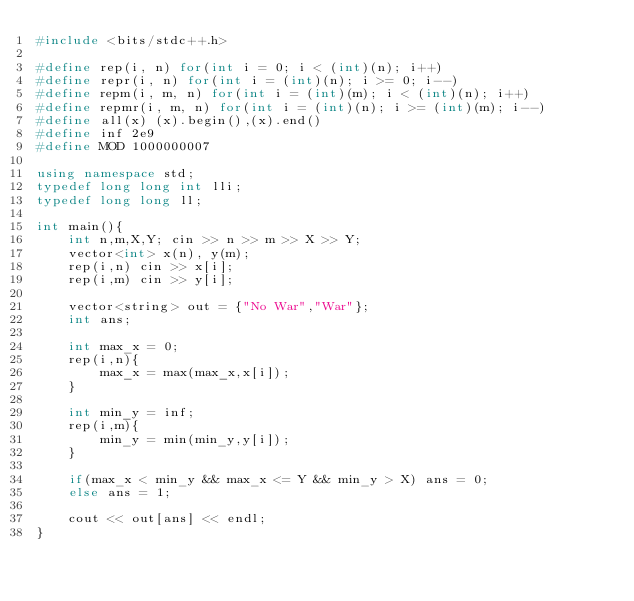<code> <loc_0><loc_0><loc_500><loc_500><_C++_>#include <bits/stdc++.h>

#define rep(i, n) for(int i = 0; i < (int)(n); i++)
#define repr(i, n) for(int i = (int)(n); i >= 0; i--)
#define repm(i, m, n) for(int i = (int)(m); i < (int)(n); i++)
#define repmr(i, m, n) for(int i = (int)(n); i >= (int)(m); i--)
#define all(x) (x).begin(),(x).end()
#define inf 2e9
#define MOD 1000000007

using namespace std;
typedef long long int lli;
typedef long long ll;

int main(){
    int n,m,X,Y; cin >> n >> m >> X >> Y;
    vector<int> x(n), y(m); 
    rep(i,n) cin >> x[i];
    rep(i,m) cin >> y[i];

    vector<string> out = {"No War","War"};
    int ans;

    int max_x = 0;
    rep(i,n){
        max_x = max(max_x,x[i]);
    }

    int min_y = inf;
    rep(i,m){
        min_y = min(min_y,y[i]);
    }

    if(max_x < min_y && max_x <= Y && min_y > X) ans = 0;
    else ans = 1;

    cout << out[ans] << endl;
}
</code> 